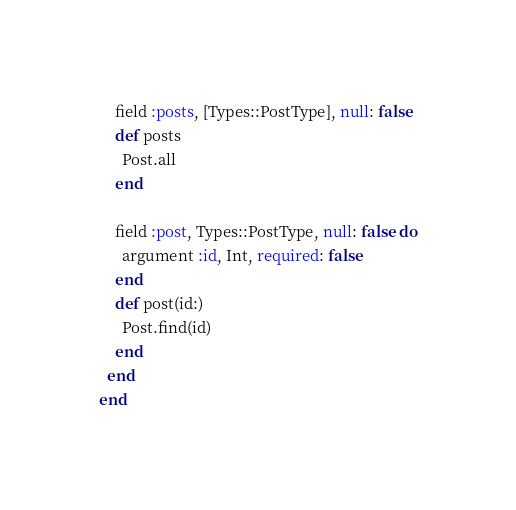<code> <loc_0><loc_0><loc_500><loc_500><_Ruby_>    field :posts, [Types::PostType], null: false
    def posts
      Post.all
    end

    field :post, Types::PostType, null: false do
      argument :id, Int, required: false
    end
    def post(id:)
      Post.find(id)
    end
  end
end
</code> 